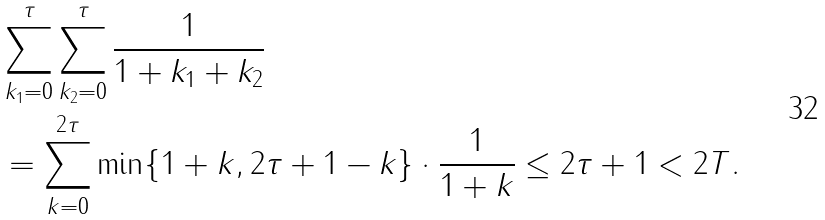<formula> <loc_0><loc_0><loc_500><loc_500>& \sum _ { k _ { 1 } = 0 } ^ { \tau } \sum _ { k _ { 2 } = 0 } ^ { \tau } \frac { 1 } { 1 + k _ { 1 } + k _ { 2 } } \\ & = \sum _ { k = 0 } ^ { 2 \tau } \min \{ 1 + k , 2 \tau + 1 - k \} \cdot \frac { 1 } { 1 + k } \leq 2 \tau + 1 < 2 T .</formula> 